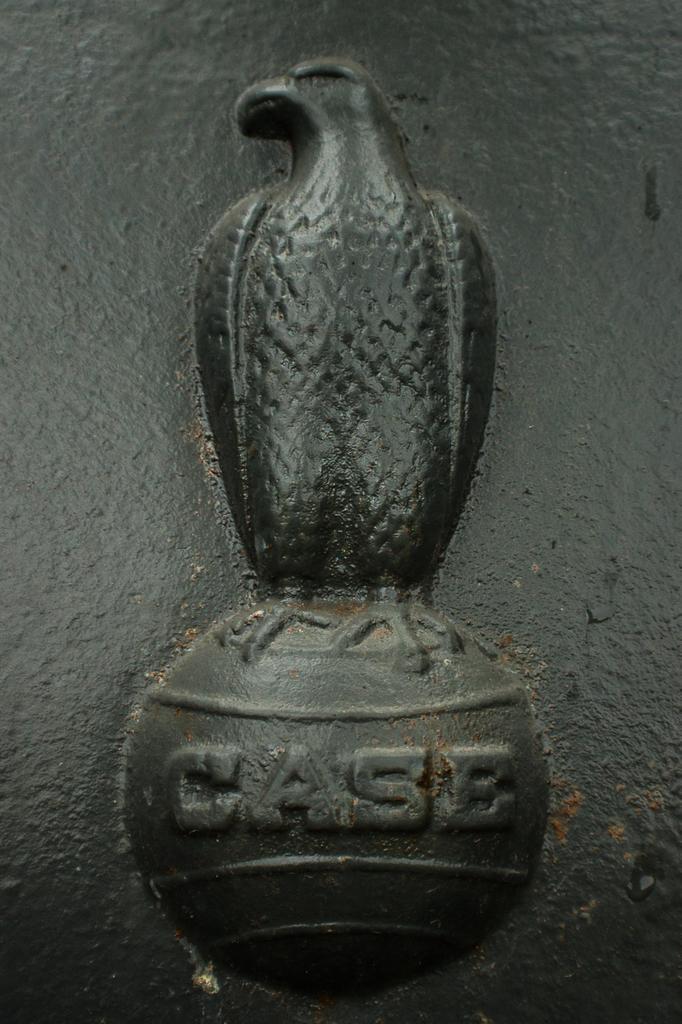Can you describe this image briefly? In this picture I can see a sculpture of a bird and I see a word written under the sculpture and I see this sculpture is of black color. 